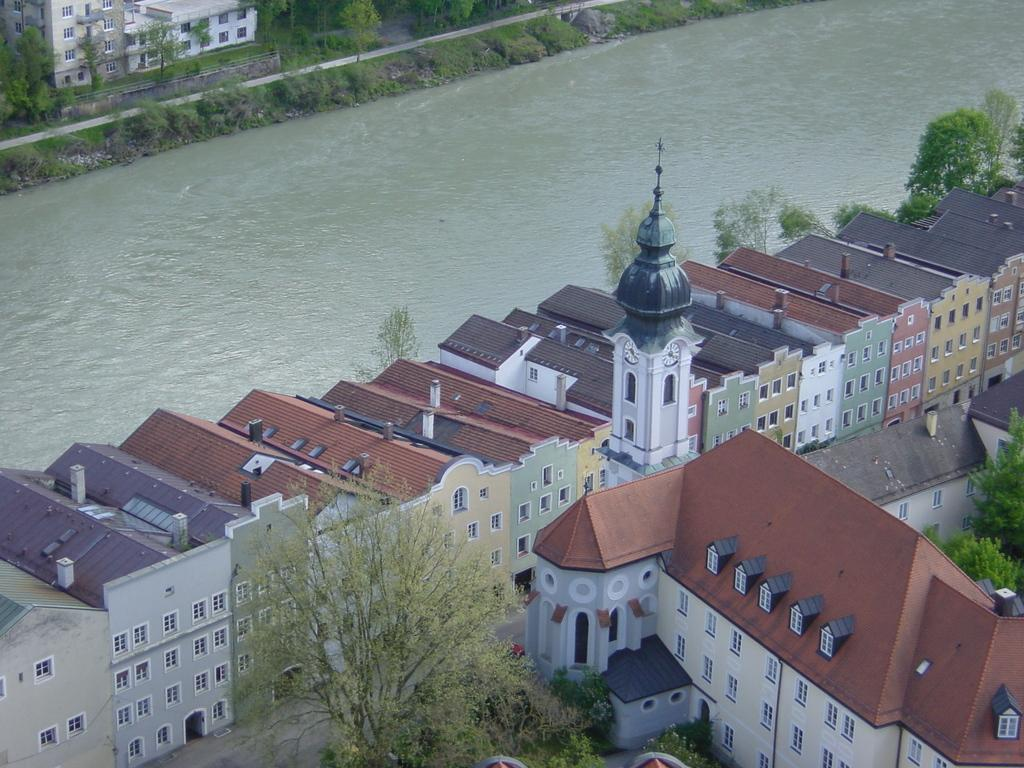What type of structures can be seen in the image? There are buildings in the image. What other natural elements are present in the image? There are trees in the image. Is there any water visible in the image? Yes, there is water visible in the image. What type of nose can be seen on the trees in the image? There are no noses present on the trees in the image, as trees do not have noses. 